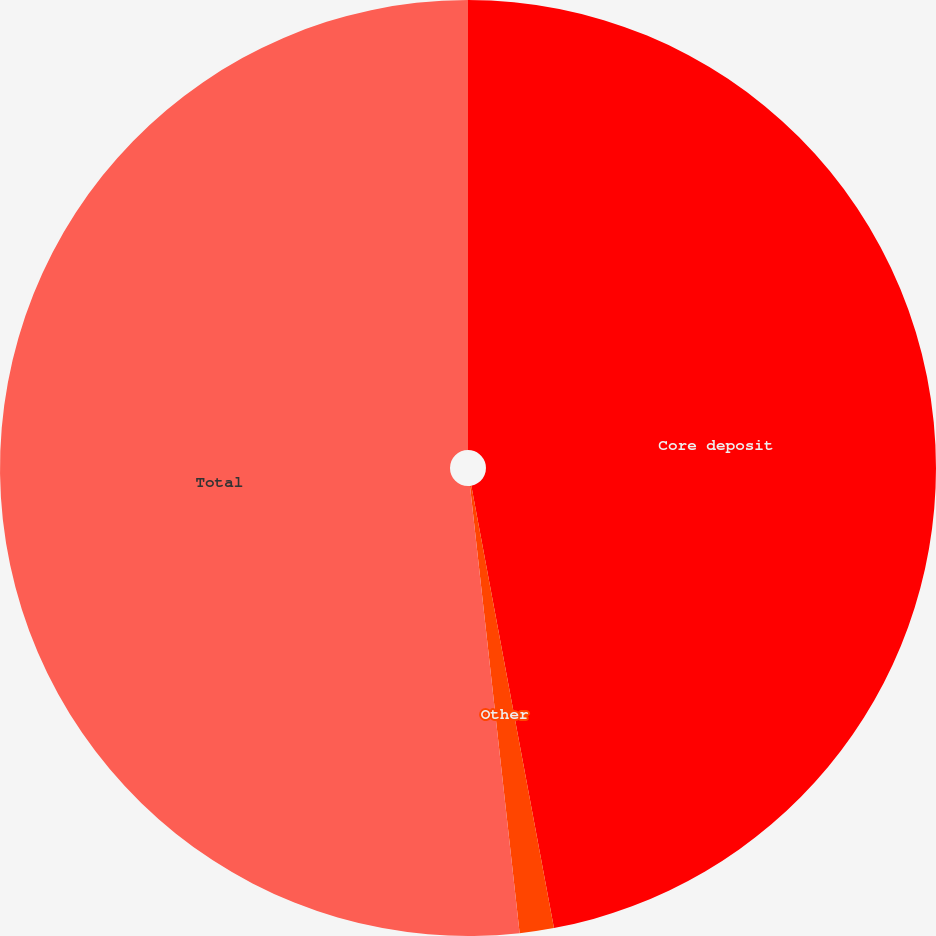Convert chart to OTSL. <chart><loc_0><loc_0><loc_500><loc_500><pie_chart><fcel>Core deposit<fcel>Other<fcel>Total<nl><fcel>47.06%<fcel>1.18%<fcel>51.76%<nl></chart> 